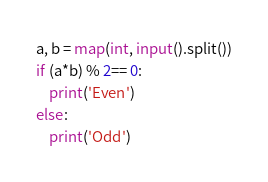<code> <loc_0><loc_0><loc_500><loc_500><_Python_>a, b = map(int, input().split())
if (a*b) % 2== 0:
    print('Even')
else:
    print('Odd')</code> 